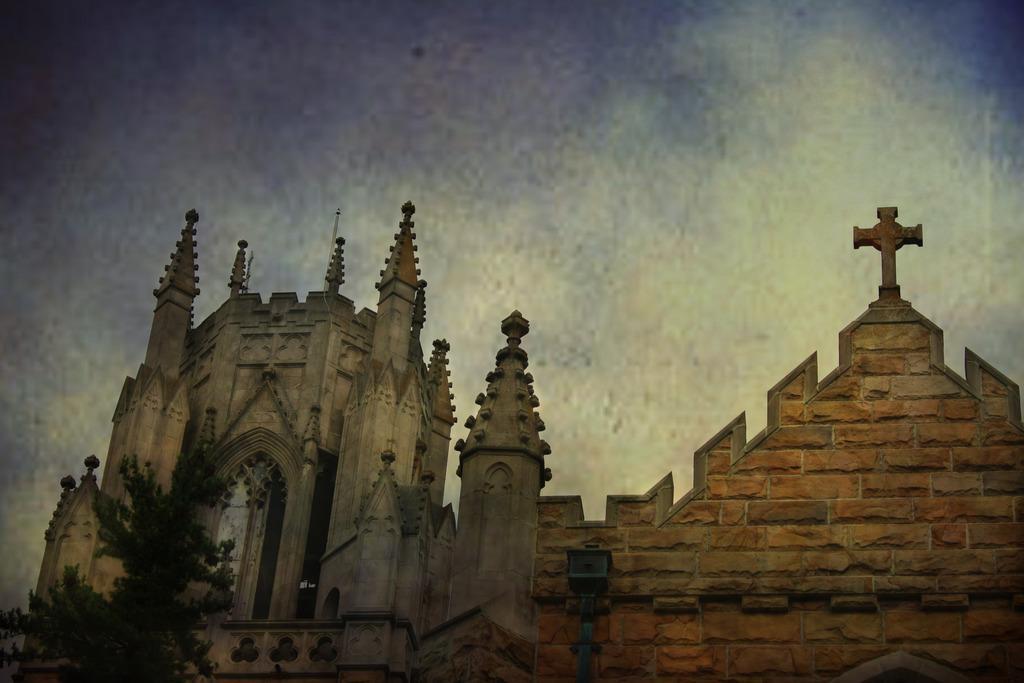Can you describe this image briefly? In this image there are buildings and we can see a tree. In the background there is sky. 